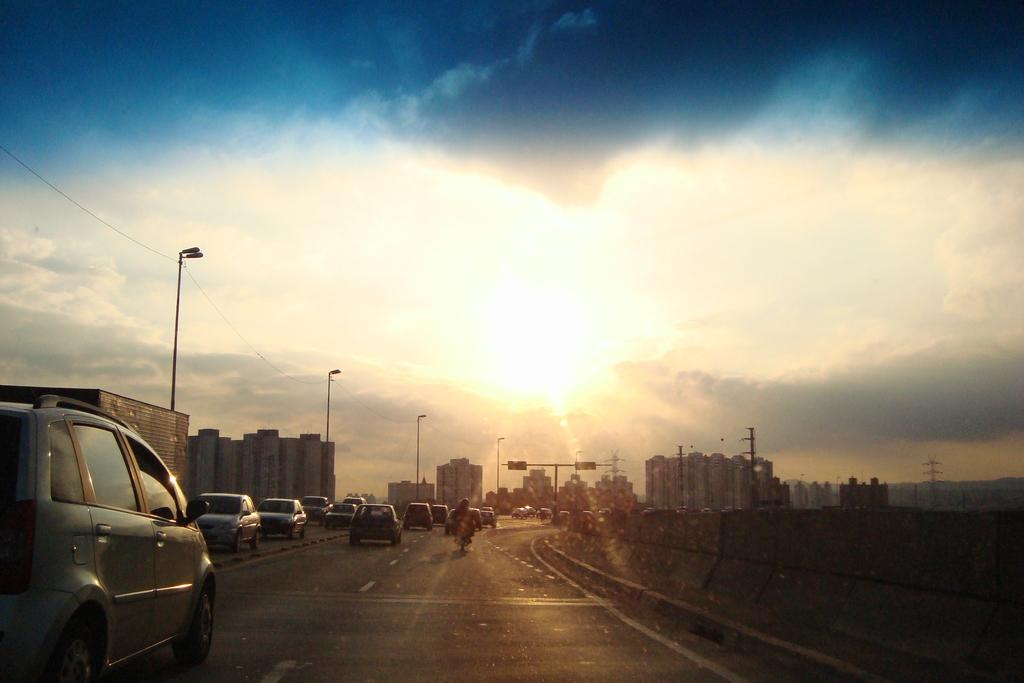What is happening at the bottom of the image? There are cars moving on the road at the bottom of the image. What can be seen on either side of the road? There are buildings on either side of the road. What is visible in the sky in the image? The sky is visible in the image, and the sun is present. Can you touch the canvas in the image? There is no canvas present in the image. What type of blade is being used by the cars in the image? The cars in the image are not using any blades; they are moving on the road using their wheels. 